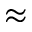<formula> <loc_0><loc_0><loc_500><loc_500>\approx</formula> 